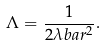<formula> <loc_0><loc_0><loc_500><loc_500>\Lambda = \frac { 1 } { 2 \lambda b a r ^ { 2 } } .</formula> 